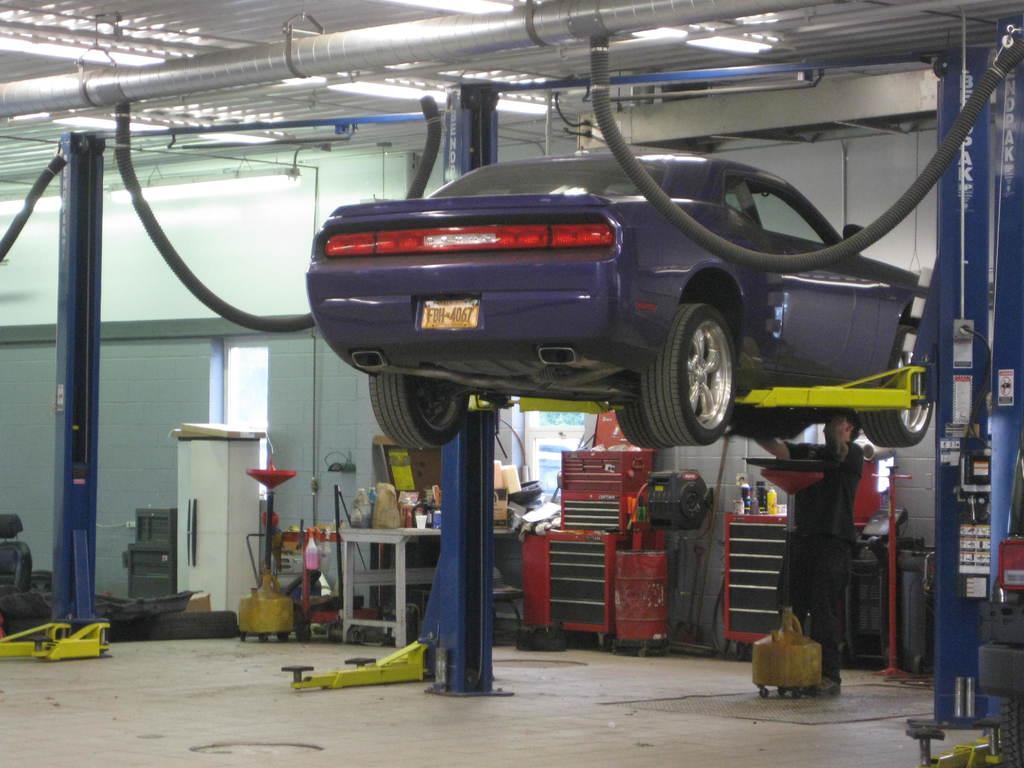Can you describe this image briefly? In this image there is floor at the bottom. There is roof at the top. There is a car in the middle and There is a person and it looks like there are metal pillars on the right corner. There are objects on the left corner. There is a table with objects on it and there is a wall in the background. 